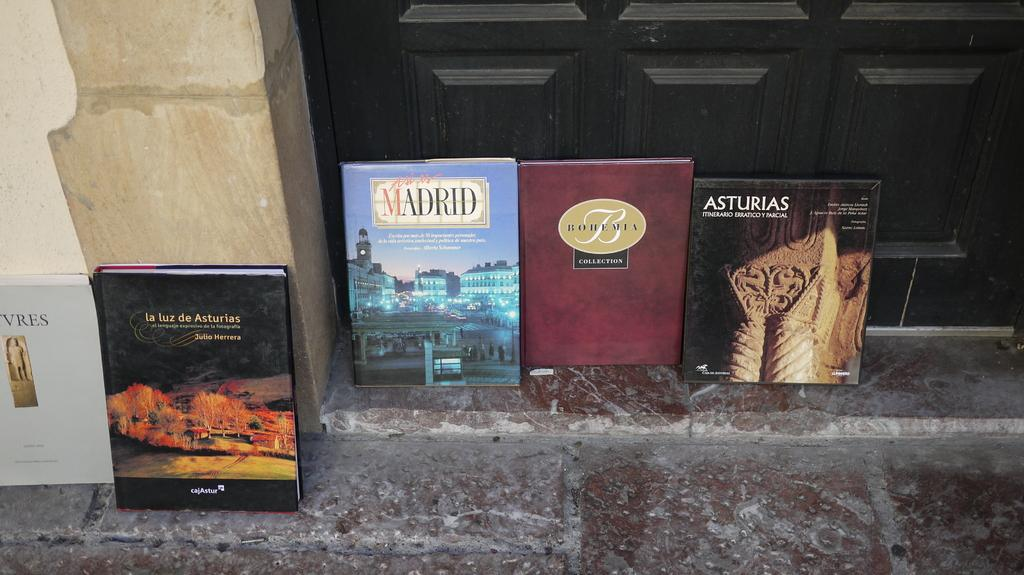Provide a one-sentence caption for the provided image. Five books about Spain are displayed by a door. 